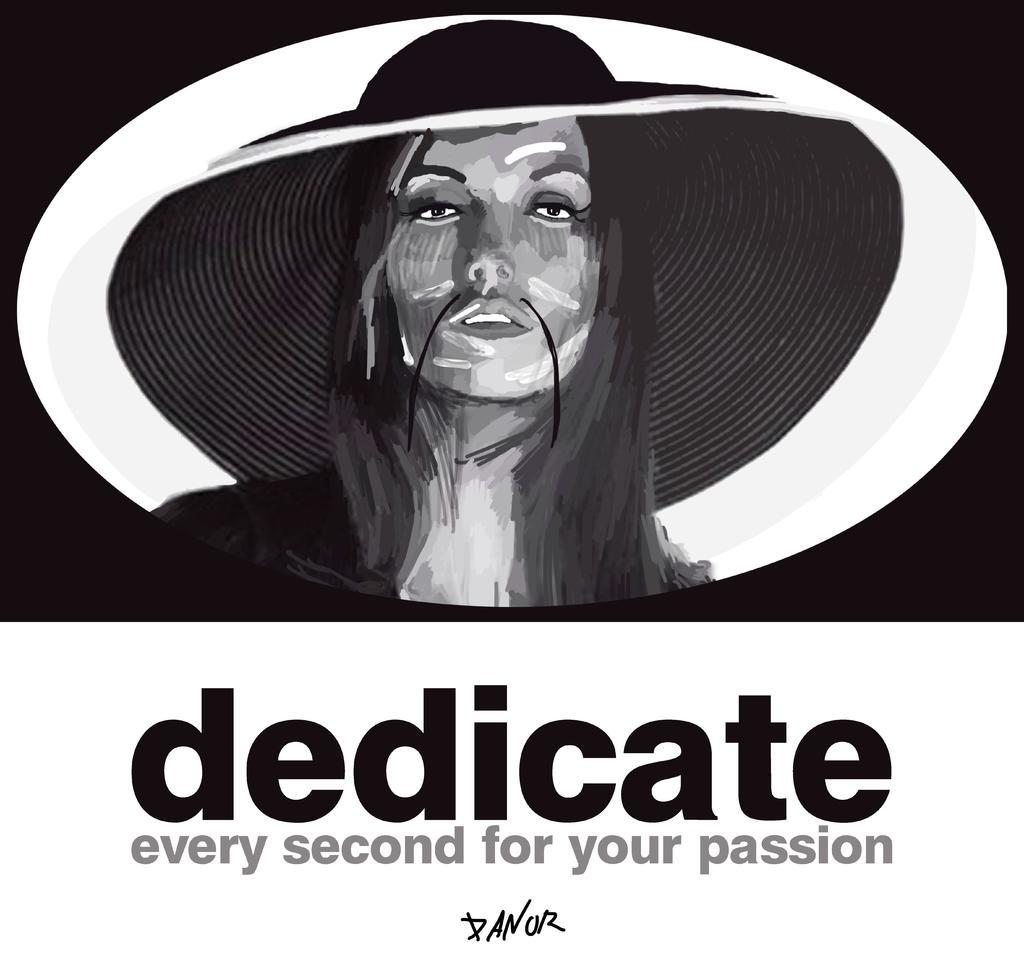Describe this image in one or two sentences. In this picture we can see a person wearing a hat. Person has a long hair. Background portion of the picture is dark. At the bottom portion of the picture there is something written. 